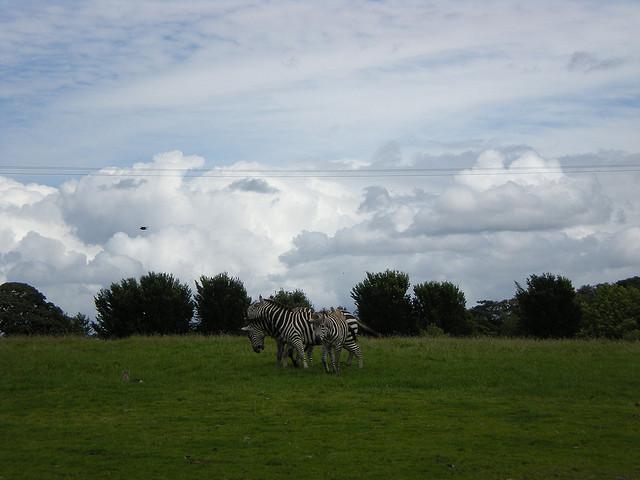Is there another group of animals nearby?
Short answer required. No. What is blocking the view of the zebra on the right?
Concise answer only. Zebra. Is it sunny in this photo?
Answer briefly. Yes. What continent are these animals grazing on?
Concise answer only. Africa. Is the zebra grazing?
Give a very brief answer. Yes. Are the zebras in captivity?
Answer briefly. No. What type of animals is this?
Be succinct. Zebra. What is standing on the hill?
Write a very short answer. Zebra. Is there a person in the image?
Give a very brief answer. No. What type of clouds are in the sky?
Answer briefly. Cumulus. What is in the background of the photo?
Keep it brief. Trees. How many dry patches are in the grass?
Quick response, please. 0. How many zebras are babies?
Keep it brief. 1. How many people are there?
Write a very short answer. 0. What animal can be seen?
Give a very brief answer. Zebra. Sunny or overcast?
Answer briefly. Overcast. Is the sky clear?
Short answer required. No. Where is the fence?
Short answer required. Nowhere. Are these giraffes?
Concise answer only. No. Where was the photo taken?
Give a very brief answer. Outside. How many zebras are in the picture?
Be succinct. 3. What type of animals are pictured?
Write a very short answer. Zebras. What kind of animal is this?
Keep it brief. Zebra. What are these animals called?
Short answer required. Zebra. What is the young zebra doing?
Quick response, please. Walking. 